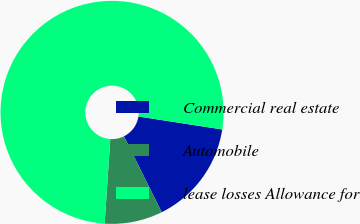<chart> <loc_0><loc_0><loc_500><loc_500><pie_chart><fcel>Commercial real estate<fcel>Automobile<fcel>lease losses Allowance for<nl><fcel>15.2%<fcel>8.4%<fcel>76.39%<nl></chart> 